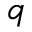Convert formula to latex. <formula><loc_0><loc_0><loc_500><loc_500>q</formula> 